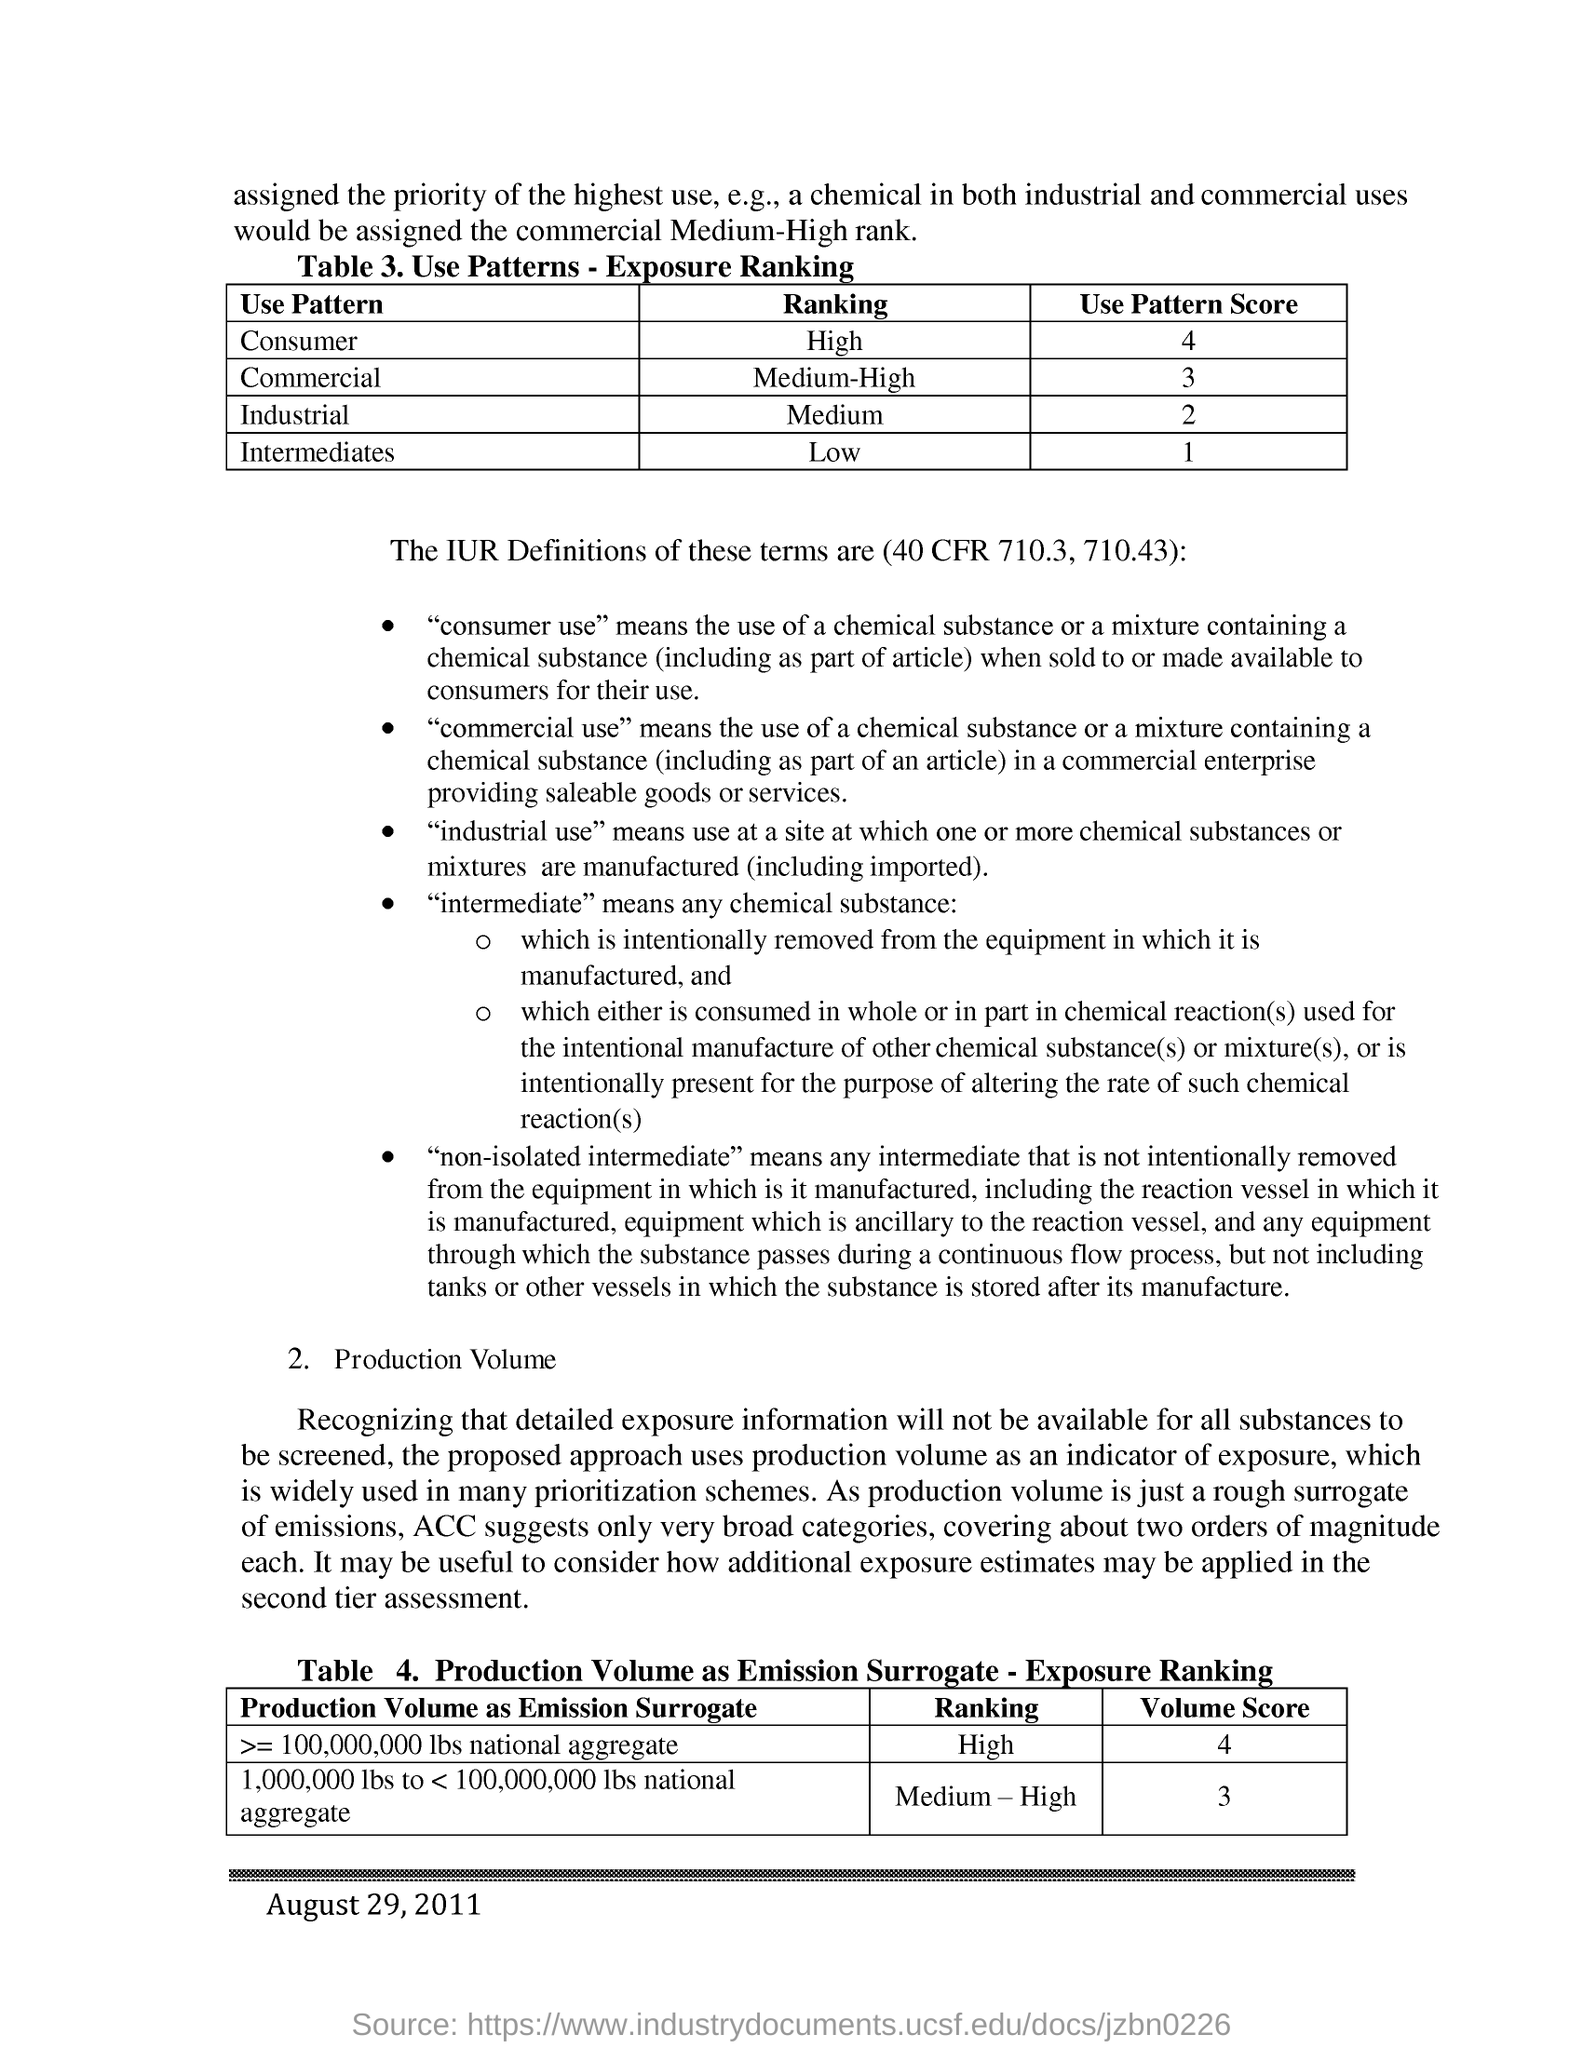Highlight a few significant elements in this photo. The use pattern ranking of consumers is high. The use pattern score of the consumer is 4 out of 5. The use of commercial is considered to have a medium-high use pattern ranking. The use pattern ranking of intermediates is low. The use pattern score for industrial applications is 2. 